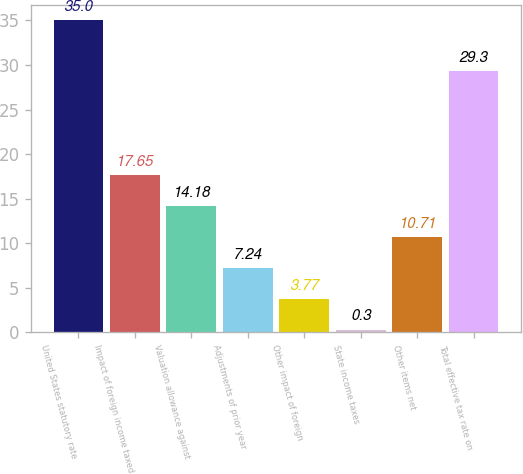Convert chart. <chart><loc_0><loc_0><loc_500><loc_500><bar_chart><fcel>United States statutory rate<fcel>Impact of foreign income taxed<fcel>Valuation allowance against<fcel>Adjustments of prior year<fcel>Other impact of foreign<fcel>State income taxes<fcel>Other items net<fcel>Total effective tax rate on<nl><fcel>35<fcel>17.65<fcel>14.18<fcel>7.24<fcel>3.77<fcel>0.3<fcel>10.71<fcel>29.3<nl></chart> 